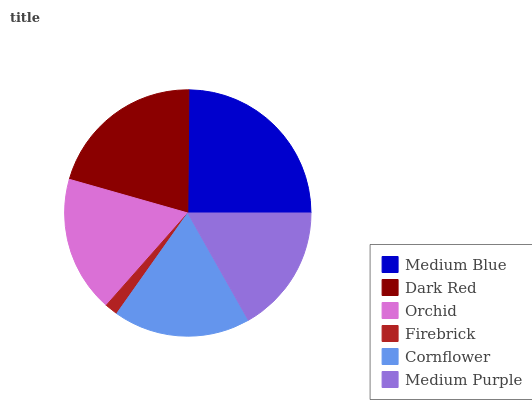Is Firebrick the minimum?
Answer yes or no. Yes. Is Medium Blue the maximum?
Answer yes or no. Yes. Is Dark Red the minimum?
Answer yes or no. No. Is Dark Red the maximum?
Answer yes or no. No. Is Medium Blue greater than Dark Red?
Answer yes or no. Yes. Is Dark Red less than Medium Blue?
Answer yes or no. Yes. Is Dark Red greater than Medium Blue?
Answer yes or no. No. Is Medium Blue less than Dark Red?
Answer yes or no. No. Is Cornflower the high median?
Answer yes or no. Yes. Is Orchid the low median?
Answer yes or no. Yes. Is Medium Purple the high median?
Answer yes or no. No. Is Cornflower the low median?
Answer yes or no. No. 